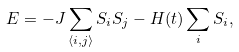Convert formula to latex. <formula><loc_0><loc_0><loc_500><loc_500>E = - J \sum _ { \langle i , j \rangle } S _ { i } S _ { j } - H ( t ) \sum _ { i } S _ { i } ,</formula> 